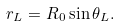Convert formula to latex. <formula><loc_0><loc_0><loc_500><loc_500>r _ { L } = R _ { 0 } \sin \theta _ { L } .</formula> 